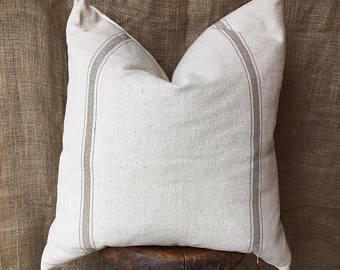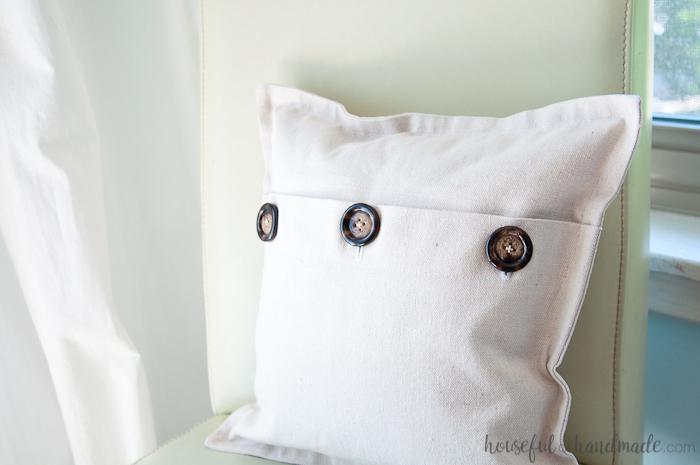The first image is the image on the left, the second image is the image on the right. Analyze the images presented: Is the assertion "The pillow in one of the images has three buttons." valid? Answer yes or no. Yes. The first image is the image on the left, the second image is the image on the right. Considering the images on both sides, is "One image features a white square pillow with three button closure that is propped against the back of a white chair." valid? Answer yes or no. Yes. 